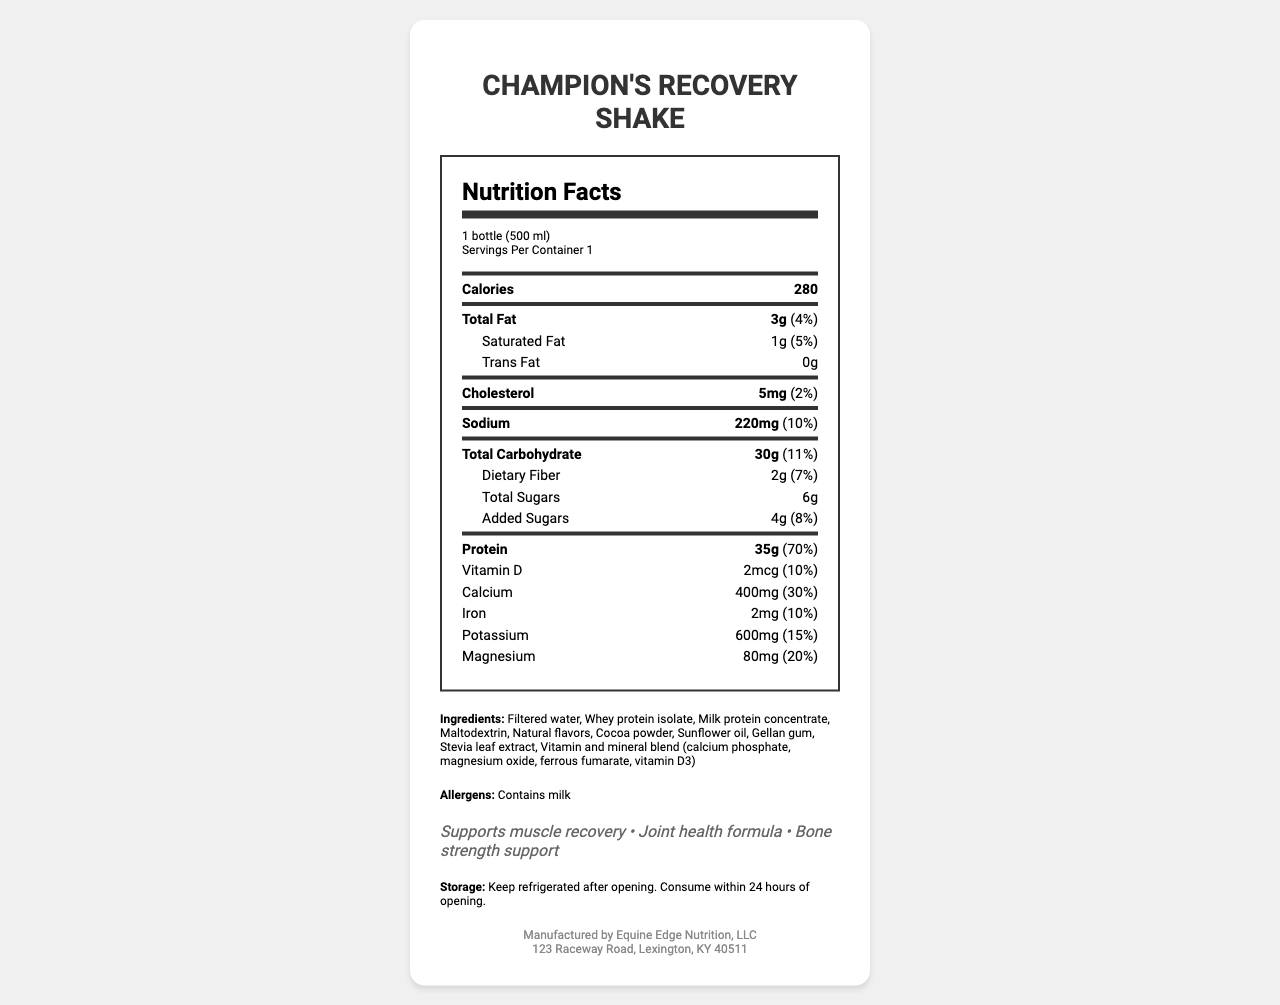what is the serving size? The serving size is listed as "1 bottle (500 ml)" in the nutrition label.
Answer: 1 bottle (500 ml) how many calories are in one serving? The document specifies that one serving contains 280 calories.
Answer: 280 what is the total fat content and its daily value percentage? The total fat content is 3g, and it provides 4% of the daily value.
Answer: 3g, 4% how much protein does one serving contain? The protein content per serving is listed as 35g.
Answer: 35g which company manufactures this product? The manufacturer is given as Equine Edge Nutrition, LLC, located at 123 Raceway Road, Lexington, KY 40511.
Answer: Equine Edge Nutrition, LLC what is the amount of added sugars in one serving? A. 2g B. 4g C. 6g The amount of added sugars is 4g.
Answer: B what are some of the claims made on this product? A. Low-calorie B. Supports muscle recovery C. Bone strength support D. High sugar content The claims listed are "Supports muscle recovery" and "Bone strength support."
Answer: B, C does this product contain any allergens? The document states that this product contains milk as an allergen.
Answer: Yes how long should you consume the shake after opening? The storage instructions recommend consuming the shake within 24 hours of opening.
Answer: Within 24 hours describe the key nutritional benefits of Champion's Recovery Shake. The main benefits include muscle recovery, joint health, and bone strength, supported by high protein content and various vitamins and minerals.
Answer: Champion's Recovery Shake is designed to support muscle recovery, joint health, and bone strength. It contains a high amount of protein (35g), essential vitamins, and minerals like calcium, iron, and magnesium. what is the source of vitamin D in this product? The document lists vitamin D3 in the vitamin and mineral blend but does not specify its source.
Answer: Not specified how does the sodium content compare to the daily value? The sodium content is 220mg, which represents 10% of the daily value.
Answer: 10% is this product suitable for vegetarians? The document does not specify if the ingredients used are vegan or vegetarian-friendly. Although it contains milk derivatives, it does not specifically mention if it is suitable for vegetarians.
Answer: Cannot be determined 